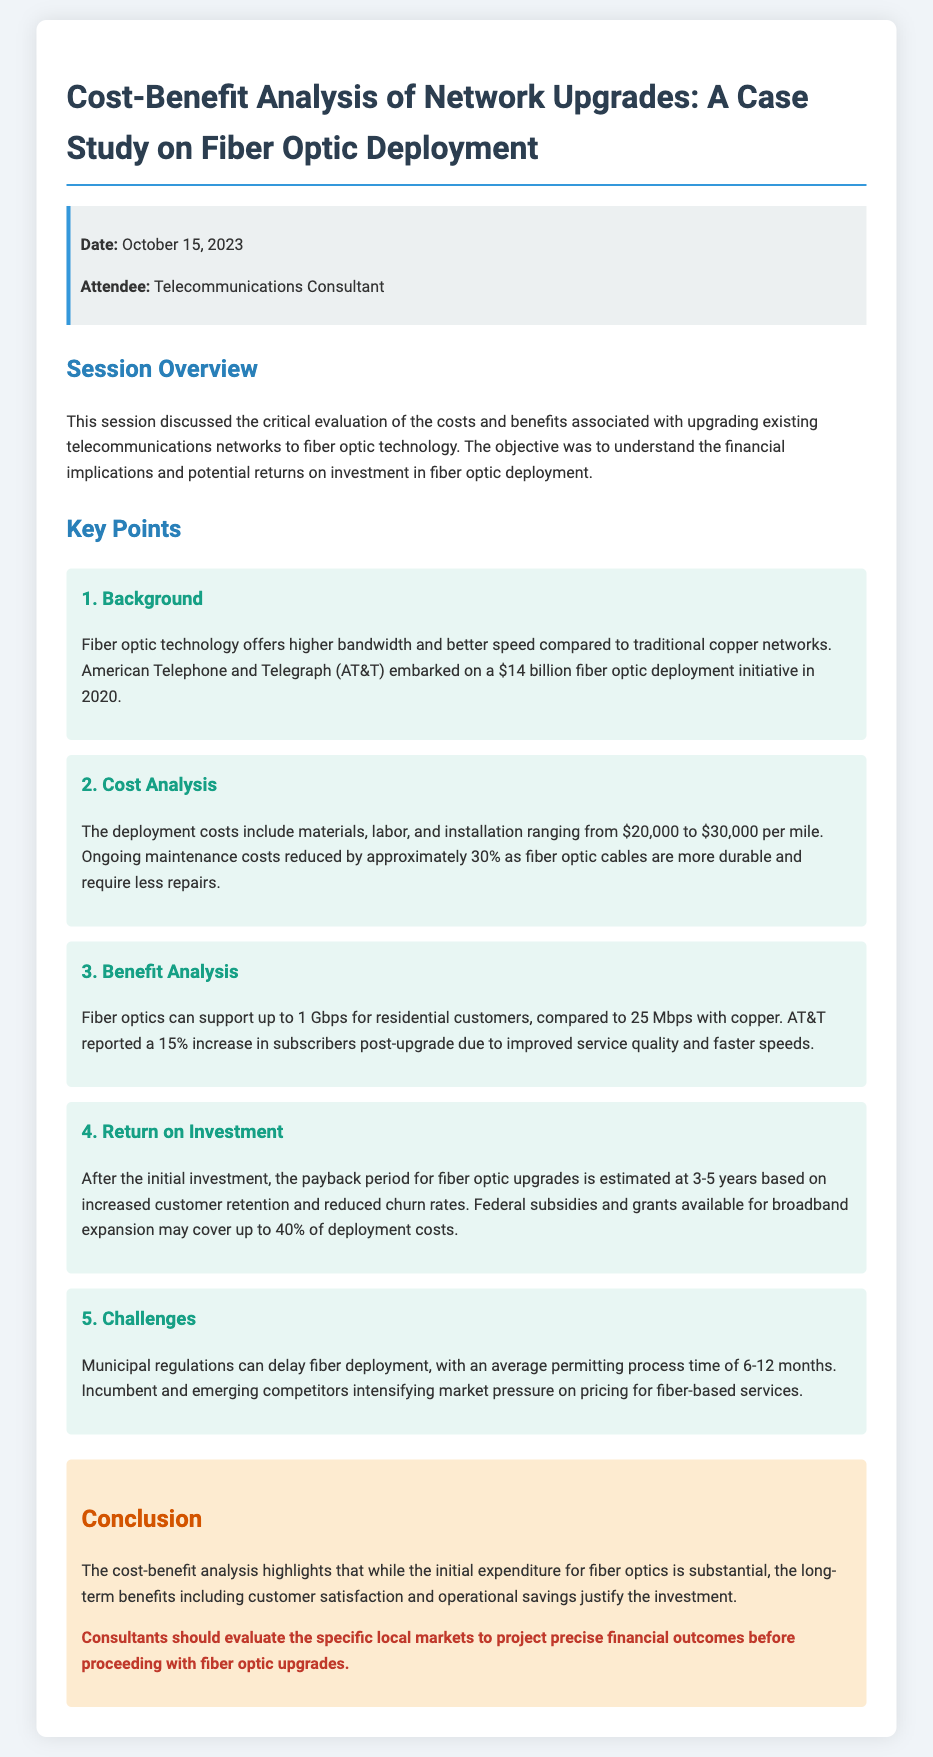What was the date of the session? The date is specified in the meta-info section of the document.
Answer: October 15, 2023 What was the initial investment cost for AT&T’s fiber optic deployment? The investment cost is mentioned in the background section of the document.
Answer: $14 billion What is the cost range for deployment per mile? The cost range is detailed in the cost analysis section of the document.
Answer: $20,000 to $30,000 What percentage increase in subscribers did AT&T report post-upgrade? This information is provided in the benefit analysis section of the document.
Answer: 15% What is the estimated payback period for fiber optic upgrades? The payback period is mentioned in the return on investment section of the document.
Answer: 3-5 years What percentage of deployment costs can be covered by federal subsidies? This detail is given in the return on investment section of the document.
Answer: Up to 40% What is a major challenge mentioned regarding fiber deployment? The challenges are outlined in the challenges section of the document.
Answer: Municipal regulations Which technology offers higher bandwidth, fiber optic or copper? This distinction is made in the background section.
Answer: Fiber optic What type of meeting document is this? The nature of the document is indicated in the title and overall structure.
Answer: Meeting minutes 